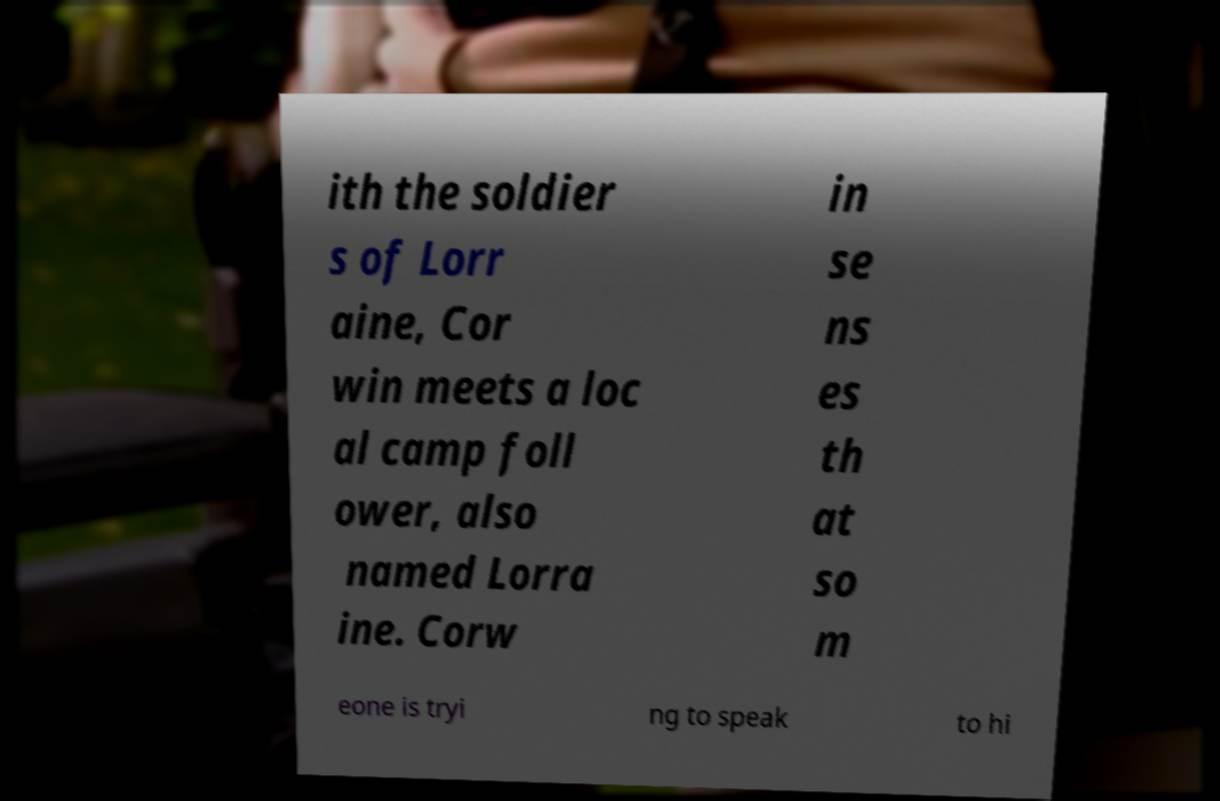There's text embedded in this image that I need extracted. Can you transcribe it verbatim? ith the soldier s of Lorr aine, Cor win meets a loc al camp foll ower, also named Lorra ine. Corw in se ns es th at so m eone is tryi ng to speak to hi 